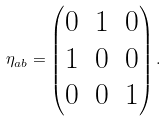Convert formula to latex. <formula><loc_0><loc_0><loc_500><loc_500>\eta _ { a b } = \left ( \begin{matrix} 0 & 1 & 0 \\ 1 & 0 & 0 \\ 0 & 0 & 1 \\ \end{matrix} \right ) .</formula> 